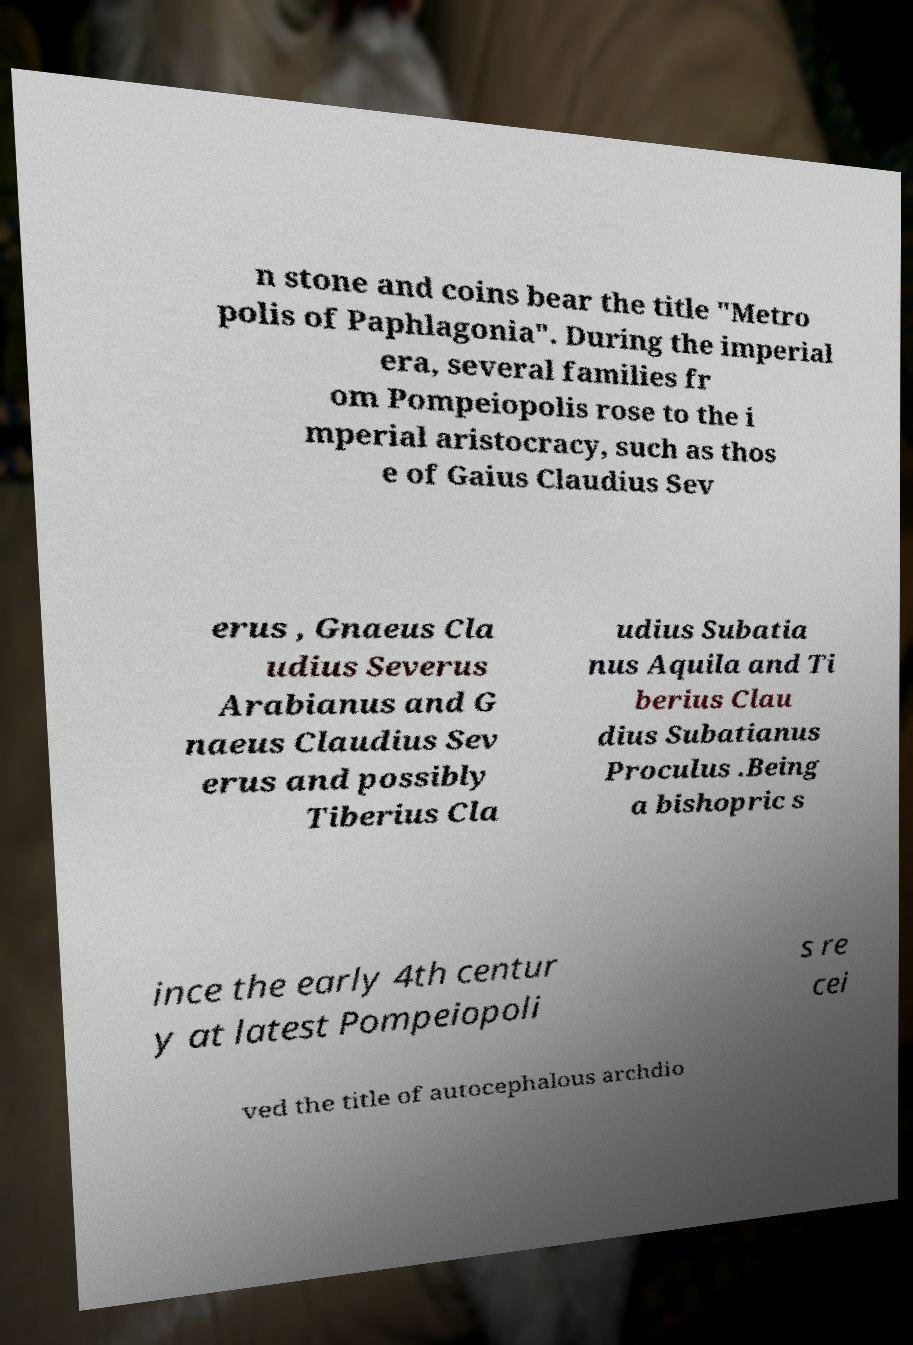Please identify and transcribe the text found in this image. n stone and coins bear the title "Metro polis of Paphlagonia". During the imperial era, several families fr om Pompeiopolis rose to the i mperial aristocracy, such as thos e of Gaius Claudius Sev erus , Gnaeus Cla udius Severus Arabianus and G naeus Claudius Sev erus and possibly Tiberius Cla udius Subatia nus Aquila and Ti berius Clau dius Subatianus Proculus .Being a bishopric s ince the early 4th centur y at latest Pompeiopoli s re cei ved the title of autocephalous archdio 